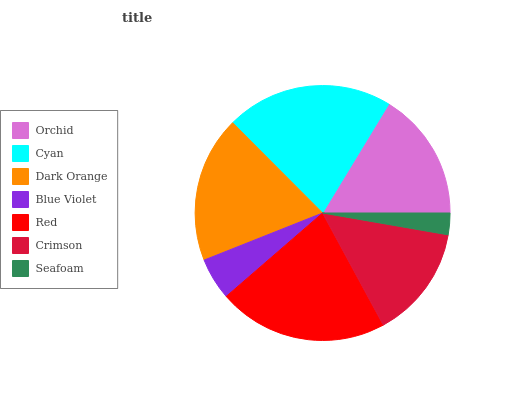Is Seafoam the minimum?
Answer yes or no. Yes. Is Red the maximum?
Answer yes or no. Yes. Is Cyan the minimum?
Answer yes or no. No. Is Cyan the maximum?
Answer yes or no. No. Is Cyan greater than Orchid?
Answer yes or no. Yes. Is Orchid less than Cyan?
Answer yes or no. Yes. Is Orchid greater than Cyan?
Answer yes or no. No. Is Cyan less than Orchid?
Answer yes or no. No. Is Orchid the high median?
Answer yes or no. Yes. Is Orchid the low median?
Answer yes or no. Yes. Is Red the high median?
Answer yes or no. No. Is Red the low median?
Answer yes or no. No. 